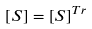Convert formula to latex. <formula><loc_0><loc_0><loc_500><loc_500>\left [ S \right ] = \left [ S \right ] ^ { T r }</formula> 